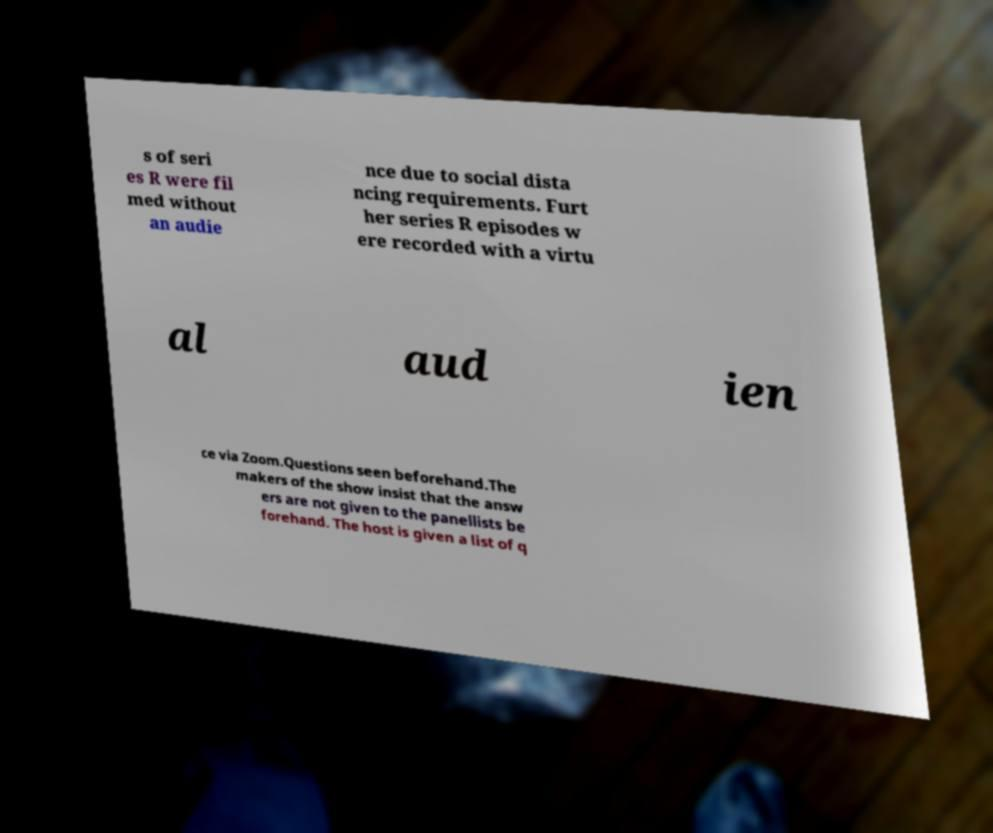Please identify and transcribe the text found in this image. s of seri es R were fil med without an audie nce due to social dista ncing requirements. Furt her series R episodes w ere recorded with a virtu al aud ien ce via Zoom.Questions seen beforehand.The makers of the show insist that the answ ers are not given to the panellists be forehand. The host is given a list of q 